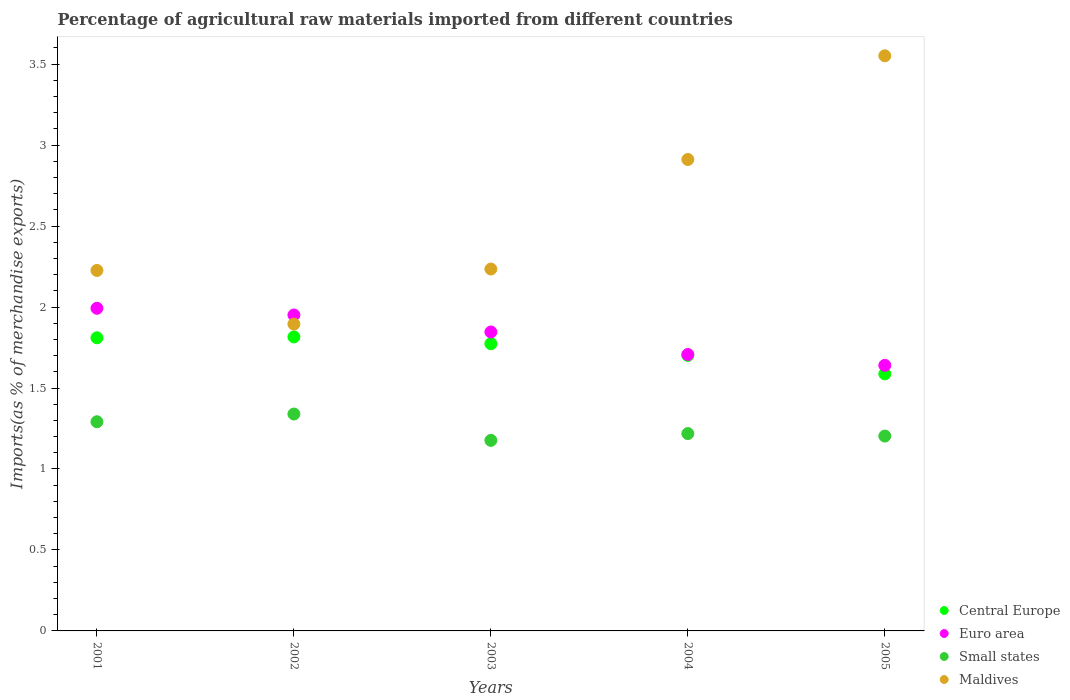How many different coloured dotlines are there?
Give a very brief answer. 4. What is the percentage of imports to different countries in Small states in 2001?
Keep it short and to the point. 1.29. Across all years, what is the maximum percentage of imports to different countries in Central Europe?
Your answer should be very brief. 1.82. Across all years, what is the minimum percentage of imports to different countries in Euro area?
Give a very brief answer. 1.64. In which year was the percentage of imports to different countries in Maldives minimum?
Give a very brief answer. 2002. What is the total percentage of imports to different countries in Maldives in the graph?
Make the answer very short. 12.82. What is the difference between the percentage of imports to different countries in Small states in 2002 and that in 2003?
Provide a short and direct response. 0.16. What is the difference between the percentage of imports to different countries in Small states in 2002 and the percentage of imports to different countries in Maldives in 2003?
Make the answer very short. -0.9. What is the average percentage of imports to different countries in Maldives per year?
Give a very brief answer. 2.56. In the year 2005, what is the difference between the percentage of imports to different countries in Central Europe and percentage of imports to different countries in Euro area?
Your response must be concise. -0.05. In how many years, is the percentage of imports to different countries in Maldives greater than 1.1 %?
Your answer should be very brief. 5. What is the ratio of the percentage of imports to different countries in Small states in 2004 to that in 2005?
Offer a terse response. 1.01. Is the percentage of imports to different countries in Euro area in 2001 less than that in 2002?
Give a very brief answer. No. What is the difference between the highest and the second highest percentage of imports to different countries in Central Europe?
Your answer should be very brief. 0.01. What is the difference between the highest and the lowest percentage of imports to different countries in Maldives?
Your response must be concise. 1.66. Is the sum of the percentage of imports to different countries in Euro area in 2001 and 2004 greater than the maximum percentage of imports to different countries in Maldives across all years?
Your answer should be compact. Yes. Is it the case that in every year, the sum of the percentage of imports to different countries in Central Europe and percentage of imports to different countries in Small states  is greater than the percentage of imports to different countries in Euro area?
Your response must be concise. Yes. Does the percentage of imports to different countries in Central Europe monotonically increase over the years?
Give a very brief answer. No. Is the percentage of imports to different countries in Central Europe strictly greater than the percentage of imports to different countries in Maldives over the years?
Keep it short and to the point. No. How many dotlines are there?
Offer a terse response. 4. What is the difference between two consecutive major ticks on the Y-axis?
Your answer should be compact. 0.5. Does the graph contain any zero values?
Keep it short and to the point. No. Does the graph contain grids?
Ensure brevity in your answer.  No. How many legend labels are there?
Provide a short and direct response. 4. What is the title of the graph?
Give a very brief answer. Percentage of agricultural raw materials imported from different countries. What is the label or title of the X-axis?
Give a very brief answer. Years. What is the label or title of the Y-axis?
Your answer should be compact. Imports(as % of merchandise exports). What is the Imports(as % of merchandise exports) in Central Europe in 2001?
Your answer should be very brief. 1.81. What is the Imports(as % of merchandise exports) in Euro area in 2001?
Ensure brevity in your answer.  1.99. What is the Imports(as % of merchandise exports) in Small states in 2001?
Make the answer very short. 1.29. What is the Imports(as % of merchandise exports) of Maldives in 2001?
Provide a short and direct response. 2.23. What is the Imports(as % of merchandise exports) in Central Europe in 2002?
Offer a terse response. 1.82. What is the Imports(as % of merchandise exports) of Euro area in 2002?
Your answer should be compact. 1.95. What is the Imports(as % of merchandise exports) in Small states in 2002?
Provide a succinct answer. 1.34. What is the Imports(as % of merchandise exports) of Maldives in 2002?
Provide a succinct answer. 1.89. What is the Imports(as % of merchandise exports) in Central Europe in 2003?
Offer a terse response. 1.77. What is the Imports(as % of merchandise exports) in Euro area in 2003?
Offer a terse response. 1.85. What is the Imports(as % of merchandise exports) of Small states in 2003?
Provide a succinct answer. 1.18. What is the Imports(as % of merchandise exports) in Maldives in 2003?
Ensure brevity in your answer.  2.23. What is the Imports(as % of merchandise exports) of Central Europe in 2004?
Your answer should be compact. 1.7. What is the Imports(as % of merchandise exports) of Euro area in 2004?
Your response must be concise. 1.71. What is the Imports(as % of merchandise exports) in Small states in 2004?
Your answer should be compact. 1.22. What is the Imports(as % of merchandise exports) of Maldives in 2004?
Give a very brief answer. 2.91. What is the Imports(as % of merchandise exports) of Central Europe in 2005?
Provide a short and direct response. 1.59. What is the Imports(as % of merchandise exports) in Euro area in 2005?
Your answer should be very brief. 1.64. What is the Imports(as % of merchandise exports) in Small states in 2005?
Make the answer very short. 1.2. What is the Imports(as % of merchandise exports) in Maldives in 2005?
Give a very brief answer. 3.55. Across all years, what is the maximum Imports(as % of merchandise exports) in Central Europe?
Give a very brief answer. 1.82. Across all years, what is the maximum Imports(as % of merchandise exports) of Euro area?
Give a very brief answer. 1.99. Across all years, what is the maximum Imports(as % of merchandise exports) of Small states?
Offer a terse response. 1.34. Across all years, what is the maximum Imports(as % of merchandise exports) of Maldives?
Offer a terse response. 3.55. Across all years, what is the minimum Imports(as % of merchandise exports) of Central Europe?
Your answer should be compact. 1.59. Across all years, what is the minimum Imports(as % of merchandise exports) in Euro area?
Make the answer very short. 1.64. Across all years, what is the minimum Imports(as % of merchandise exports) in Small states?
Your answer should be very brief. 1.18. Across all years, what is the minimum Imports(as % of merchandise exports) of Maldives?
Offer a very short reply. 1.89. What is the total Imports(as % of merchandise exports) of Central Europe in the graph?
Ensure brevity in your answer.  8.69. What is the total Imports(as % of merchandise exports) in Euro area in the graph?
Offer a very short reply. 9.14. What is the total Imports(as % of merchandise exports) in Small states in the graph?
Offer a very short reply. 6.23. What is the total Imports(as % of merchandise exports) in Maldives in the graph?
Give a very brief answer. 12.82. What is the difference between the Imports(as % of merchandise exports) of Central Europe in 2001 and that in 2002?
Offer a terse response. -0.01. What is the difference between the Imports(as % of merchandise exports) of Euro area in 2001 and that in 2002?
Offer a terse response. 0.04. What is the difference between the Imports(as % of merchandise exports) of Small states in 2001 and that in 2002?
Offer a terse response. -0.05. What is the difference between the Imports(as % of merchandise exports) in Maldives in 2001 and that in 2002?
Your response must be concise. 0.33. What is the difference between the Imports(as % of merchandise exports) of Central Europe in 2001 and that in 2003?
Your answer should be compact. 0.04. What is the difference between the Imports(as % of merchandise exports) of Euro area in 2001 and that in 2003?
Make the answer very short. 0.15. What is the difference between the Imports(as % of merchandise exports) of Small states in 2001 and that in 2003?
Your answer should be very brief. 0.12. What is the difference between the Imports(as % of merchandise exports) in Maldives in 2001 and that in 2003?
Your response must be concise. -0.01. What is the difference between the Imports(as % of merchandise exports) of Central Europe in 2001 and that in 2004?
Keep it short and to the point. 0.11. What is the difference between the Imports(as % of merchandise exports) of Euro area in 2001 and that in 2004?
Offer a terse response. 0.29. What is the difference between the Imports(as % of merchandise exports) of Small states in 2001 and that in 2004?
Make the answer very short. 0.07. What is the difference between the Imports(as % of merchandise exports) of Maldives in 2001 and that in 2004?
Offer a very short reply. -0.69. What is the difference between the Imports(as % of merchandise exports) of Central Europe in 2001 and that in 2005?
Your response must be concise. 0.22. What is the difference between the Imports(as % of merchandise exports) of Euro area in 2001 and that in 2005?
Make the answer very short. 0.35. What is the difference between the Imports(as % of merchandise exports) in Small states in 2001 and that in 2005?
Keep it short and to the point. 0.09. What is the difference between the Imports(as % of merchandise exports) in Maldives in 2001 and that in 2005?
Your response must be concise. -1.33. What is the difference between the Imports(as % of merchandise exports) of Central Europe in 2002 and that in 2003?
Give a very brief answer. 0.04. What is the difference between the Imports(as % of merchandise exports) of Euro area in 2002 and that in 2003?
Provide a succinct answer. 0.11. What is the difference between the Imports(as % of merchandise exports) in Small states in 2002 and that in 2003?
Provide a succinct answer. 0.16. What is the difference between the Imports(as % of merchandise exports) of Maldives in 2002 and that in 2003?
Your response must be concise. -0.34. What is the difference between the Imports(as % of merchandise exports) in Central Europe in 2002 and that in 2004?
Provide a succinct answer. 0.11. What is the difference between the Imports(as % of merchandise exports) in Euro area in 2002 and that in 2004?
Provide a short and direct response. 0.24. What is the difference between the Imports(as % of merchandise exports) of Small states in 2002 and that in 2004?
Your answer should be compact. 0.12. What is the difference between the Imports(as % of merchandise exports) of Maldives in 2002 and that in 2004?
Offer a terse response. -1.02. What is the difference between the Imports(as % of merchandise exports) in Central Europe in 2002 and that in 2005?
Provide a succinct answer. 0.23. What is the difference between the Imports(as % of merchandise exports) in Euro area in 2002 and that in 2005?
Make the answer very short. 0.31. What is the difference between the Imports(as % of merchandise exports) of Small states in 2002 and that in 2005?
Make the answer very short. 0.14. What is the difference between the Imports(as % of merchandise exports) of Maldives in 2002 and that in 2005?
Provide a succinct answer. -1.66. What is the difference between the Imports(as % of merchandise exports) of Central Europe in 2003 and that in 2004?
Make the answer very short. 0.07. What is the difference between the Imports(as % of merchandise exports) in Euro area in 2003 and that in 2004?
Your answer should be very brief. 0.14. What is the difference between the Imports(as % of merchandise exports) of Small states in 2003 and that in 2004?
Make the answer very short. -0.04. What is the difference between the Imports(as % of merchandise exports) of Maldives in 2003 and that in 2004?
Provide a succinct answer. -0.68. What is the difference between the Imports(as % of merchandise exports) in Central Europe in 2003 and that in 2005?
Give a very brief answer. 0.19. What is the difference between the Imports(as % of merchandise exports) in Euro area in 2003 and that in 2005?
Make the answer very short. 0.21. What is the difference between the Imports(as % of merchandise exports) of Small states in 2003 and that in 2005?
Your answer should be compact. -0.03. What is the difference between the Imports(as % of merchandise exports) in Maldives in 2003 and that in 2005?
Keep it short and to the point. -1.32. What is the difference between the Imports(as % of merchandise exports) in Central Europe in 2004 and that in 2005?
Make the answer very short. 0.11. What is the difference between the Imports(as % of merchandise exports) in Euro area in 2004 and that in 2005?
Offer a very short reply. 0.07. What is the difference between the Imports(as % of merchandise exports) of Small states in 2004 and that in 2005?
Make the answer very short. 0.02. What is the difference between the Imports(as % of merchandise exports) of Maldives in 2004 and that in 2005?
Offer a terse response. -0.64. What is the difference between the Imports(as % of merchandise exports) in Central Europe in 2001 and the Imports(as % of merchandise exports) in Euro area in 2002?
Offer a very short reply. -0.14. What is the difference between the Imports(as % of merchandise exports) in Central Europe in 2001 and the Imports(as % of merchandise exports) in Small states in 2002?
Keep it short and to the point. 0.47. What is the difference between the Imports(as % of merchandise exports) in Central Europe in 2001 and the Imports(as % of merchandise exports) in Maldives in 2002?
Keep it short and to the point. -0.08. What is the difference between the Imports(as % of merchandise exports) of Euro area in 2001 and the Imports(as % of merchandise exports) of Small states in 2002?
Provide a short and direct response. 0.65. What is the difference between the Imports(as % of merchandise exports) of Euro area in 2001 and the Imports(as % of merchandise exports) of Maldives in 2002?
Make the answer very short. 0.1. What is the difference between the Imports(as % of merchandise exports) in Small states in 2001 and the Imports(as % of merchandise exports) in Maldives in 2002?
Your answer should be very brief. -0.6. What is the difference between the Imports(as % of merchandise exports) of Central Europe in 2001 and the Imports(as % of merchandise exports) of Euro area in 2003?
Give a very brief answer. -0.04. What is the difference between the Imports(as % of merchandise exports) of Central Europe in 2001 and the Imports(as % of merchandise exports) of Small states in 2003?
Give a very brief answer. 0.63. What is the difference between the Imports(as % of merchandise exports) of Central Europe in 2001 and the Imports(as % of merchandise exports) of Maldives in 2003?
Provide a succinct answer. -0.42. What is the difference between the Imports(as % of merchandise exports) in Euro area in 2001 and the Imports(as % of merchandise exports) in Small states in 2003?
Your answer should be very brief. 0.82. What is the difference between the Imports(as % of merchandise exports) in Euro area in 2001 and the Imports(as % of merchandise exports) in Maldives in 2003?
Offer a terse response. -0.24. What is the difference between the Imports(as % of merchandise exports) in Small states in 2001 and the Imports(as % of merchandise exports) in Maldives in 2003?
Provide a short and direct response. -0.94. What is the difference between the Imports(as % of merchandise exports) of Central Europe in 2001 and the Imports(as % of merchandise exports) of Euro area in 2004?
Your answer should be compact. 0.1. What is the difference between the Imports(as % of merchandise exports) of Central Europe in 2001 and the Imports(as % of merchandise exports) of Small states in 2004?
Keep it short and to the point. 0.59. What is the difference between the Imports(as % of merchandise exports) of Central Europe in 2001 and the Imports(as % of merchandise exports) of Maldives in 2004?
Your response must be concise. -1.1. What is the difference between the Imports(as % of merchandise exports) in Euro area in 2001 and the Imports(as % of merchandise exports) in Small states in 2004?
Provide a succinct answer. 0.77. What is the difference between the Imports(as % of merchandise exports) in Euro area in 2001 and the Imports(as % of merchandise exports) in Maldives in 2004?
Keep it short and to the point. -0.92. What is the difference between the Imports(as % of merchandise exports) of Small states in 2001 and the Imports(as % of merchandise exports) of Maldives in 2004?
Give a very brief answer. -1.62. What is the difference between the Imports(as % of merchandise exports) in Central Europe in 2001 and the Imports(as % of merchandise exports) in Euro area in 2005?
Provide a succinct answer. 0.17. What is the difference between the Imports(as % of merchandise exports) in Central Europe in 2001 and the Imports(as % of merchandise exports) in Small states in 2005?
Ensure brevity in your answer.  0.61. What is the difference between the Imports(as % of merchandise exports) of Central Europe in 2001 and the Imports(as % of merchandise exports) of Maldives in 2005?
Offer a terse response. -1.74. What is the difference between the Imports(as % of merchandise exports) of Euro area in 2001 and the Imports(as % of merchandise exports) of Small states in 2005?
Your answer should be compact. 0.79. What is the difference between the Imports(as % of merchandise exports) of Euro area in 2001 and the Imports(as % of merchandise exports) of Maldives in 2005?
Your answer should be very brief. -1.56. What is the difference between the Imports(as % of merchandise exports) of Small states in 2001 and the Imports(as % of merchandise exports) of Maldives in 2005?
Offer a very short reply. -2.26. What is the difference between the Imports(as % of merchandise exports) in Central Europe in 2002 and the Imports(as % of merchandise exports) in Euro area in 2003?
Keep it short and to the point. -0.03. What is the difference between the Imports(as % of merchandise exports) of Central Europe in 2002 and the Imports(as % of merchandise exports) of Small states in 2003?
Your answer should be very brief. 0.64. What is the difference between the Imports(as % of merchandise exports) in Central Europe in 2002 and the Imports(as % of merchandise exports) in Maldives in 2003?
Offer a very short reply. -0.42. What is the difference between the Imports(as % of merchandise exports) in Euro area in 2002 and the Imports(as % of merchandise exports) in Small states in 2003?
Ensure brevity in your answer.  0.77. What is the difference between the Imports(as % of merchandise exports) of Euro area in 2002 and the Imports(as % of merchandise exports) of Maldives in 2003?
Make the answer very short. -0.28. What is the difference between the Imports(as % of merchandise exports) of Small states in 2002 and the Imports(as % of merchandise exports) of Maldives in 2003?
Provide a short and direct response. -0.9. What is the difference between the Imports(as % of merchandise exports) in Central Europe in 2002 and the Imports(as % of merchandise exports) in Euro area in 2004?
Your response must be concise. 0.11. What is the difference between the Imports(as % of merchandise exports) of Central Europe in 2002 and the Imports(as % of merchandise exports) of Small states in 2004?
Your response must be concise. 0.6. What is the difference between the Imports(as % of merchandise exports) of Central Europe in 2002 and the Imports(as % of merchandise exports) of Maldives in 2004?
Your response must be concise. -1.1. What is the difference between the Imports(as % of merchandise exports) of Euro area in 2002 and the Imports(as % of merchandise exports) of Small states in 2004?
Offer a very short reply. 0.73. What is the difference between the Imports(as % of merchandise exports) in Euro area in 2002 and the Imports(as % of merchandise exports) in Maldives in 2004?
Offer a terse response. -0.96. What is the difference between the Imports(as % of merchandise exports) of Small states in 2002 and the Imports(as % of merchandise exports) of Maldives in 2004?
Provide a succinct answer. -1.57. What is the difference between the Imports(as % of merchandise exports) in Central Europe in 2002 and the Imports(as % of merchandise exports) in Euro area in 2005?
Make the answer very short. 0.18. What is the difference between the Imports(as % of merchandise exports) of Central Europe in 2002 and the Imports(as % of merchandise exports) of Small states in 2005?
Give a very brief answer. 0.61. What is the difference between the Imports(as % of merchandise exports) in Central Europe in 2002 and the Imports(as % of merchandise exports) in Maldives in 2005?
Ensure brevity in your answer.  -1.74. What is the difference between the Imports(as % of merchandise exports) in Euro area in 2002 and the Imports(as % of merchandise exports) in Small states in 2005?
Your answer should be very brief. 0.75. What is the difference between the Imports(as % of merchandise exports) of Euro area in 2002 and the Imports(as % of merchandise exports) of Maldives in 2005?
Keep it short and to the point. -1.6. What is the difference between the Imports(as % of merchandise exports) of Small states in 2002 and the Imports(as % of merchandise exports) of Maldives in 2005?
Offer a very short reply. -2.21. What is the difference between the Imports(as % of merchandise exports) of Central Europe in 2003 and the Imports(as % of merchandise exports) of Euro area in 2004?
Provide a succinct answer. 0.07. What is the difference between the Imports(as % of merchandise exports) in Central Europe in 2003 and the Imports(as % of merchandise exports) in Small states in 2004?
Ensure brevity in your answer.  0.56. What is the difference between the Imports(as % of merchandise exports) in Central Europe in 2003 and the Imports(as % of merchandise exports) in Maldives in 2004?
Ensure brevity in your answer.  -1.14. What is the difference between the Imports(as % of merchandise exports) in Euro area in 2003 and the Imports(as % of merchandise exports) in Small states in 2004?
Make the answer very short. 0.63. What is the difference between the Imports(as % of merchandise exports) in Euro area in 2003 and the Imports(as % of merchandise exports) in Maldives in 2004?
Provide a succinct answer. -1.07. What is the difference between the Imports(as % of merchandise exports) of Small states in 2003 and the Imports(as % of merchandise exports) of Maldives in 2004?
Ensure brevity in your answer.  -1.73. What is the difference between the Imports(as % of merchandise exports) in Central Europe in 2003 and the Imports(as % of merchandise exports) in Euro area in 2005?
Provide a succinct answer. 0.13. What is the difference between the Imports(as % of merchandise exports) of Central Europe in 2003 and the Imports(as % of merchandise exports) of Small states in 2005?
Your response must be concise. 0.57. What is the difference between the Imports(as % of merchandise exports) in Central Europe in 2003 and the Imports(as % of merchandise exports) in Maldives in 2005?
Your answer should be compact. -1.78. What is the difference between the Imports(as % of merchandise exports) of Euro area in 2003 and the Imports(as % of merchandise exports) of Small states in 2005?
Make the answer very short. 0.64. What is the difference between the Imports(as % of merchandise exports) of Euro area in 2003 and the Imports(as % of merchandise exports) of Maldives in 2005?
Provide a short and direct response. -1.71. What is the difference between the Imports(as % of merchandise exports) of Small states in 2003 and the Imports(as % of merchandise exports) of Maldives in 2005?
Offer a very short reply. -2.37. What is the difference between the Imports(as % of merchandise exports) in Central Europe in 2004 and the Imports(as % of merchandise exports) in Euro area in 2005?
Make the answer very short. 0.06. What is the difference between the Imports(as % of merchandise exports) of Central Europe in 2004 and the Imports(as % of merchandise exports) of Small states in 2005?
Your answer should be compact. 0.5. What is the difference between the Imports(as % of merchandise exports) in Central Europe in 2004 and the Imports(as % of merchandise exports) in Maldives in 2005?
Give a very brief answer. -1.85. What is the difference between the Imports(as % of merchandise exports) of Euro area in 2004 and the Imports(as % of merchandise exports) of Small states in 2005?
Provide a short and direct response. 0.5. What is the difference between the Imports(as % of merchandise exports) in Euro area in 2004 and the Imports(as % of merchandise exports) in Maldives in 2005?
Offer a very short reply. -1.84. What is the difference between the Imports(as % of merchandise exports) of Small states in 2004 and the Imports(as % of merchandise exports) of Maldives in 2005?
Offer a very short reply. -2.33. What is the average Imports(as % of merchandise exports) of Central Europe per year?
Provide a short and direct response. 1.74. What is the average Imports(as % of merchandise exports) in Euro area per year?
Provide a short and direct response. 1.83. What is the average Imports(as % of merchandise exports) of Small states per year?
Your answer should be compact. 1.25. What is the average Imports(as % of merchandise exports) of Maldives per year?
Offer a very short reply. 2.56. In the year 2001, what is the difference between the Imports(as % of merchandise exports) in Central Europe and Imports(as % of merchandise exports) in Euro area?
Your answer should be compact. -0.18. In the year 2001, what is the difference between the Imports(as % of merchandise exports) of Central Europe and Imports(as % of merchandise exports) of Small states?
Provide a succinct answer. 0.52. In the year 2001, what is the difference between the Imports(as % of merchandise exports) in Central Europe and Imports(as % of merchandise exports) in Maldives?
Offer a very short reply. -0.42. In the year 2001, what is the difference between the Imports(as % of merchandise exports) in Euro area and Imports(as % of merchandise exports) in Small states?
Offer a very short reply. 0.7. In the year 2001, what is the difference between the Imports(as % of merchandise exports) in Euro area and Imports(as % of merchandise exports) in Maldives?
Provide a succinct answer. -0.23. In the year 2001, what is the difference between the Imports(as % of merchandise exports) in Small states and Imports(as % of merchandise exports) in Maldives?
Ensure brevity in your answer.  -0.93. In the year 2002, what is the difference between the Imports(as % of merchandise exports) of Central Europe and Imports(as % of merchandise exports) of Euro area?
Your answer should be very brief. -0.14. In the year 2002, what is the difference between the Imports(as % of merchandise exports) of Central Europe and Imports(as % of merchandise exports) of Small states?
Keep it short and to the point. 0.48. In the year 2002, what is the difference between the Imports(as % of merchandise exports) in Central Europe and Imports(as % of merchandise exports) in Maldives?
Provide a short and direct response. -0.08. In the year 2002, what is the difference between the Imports(as % of merchandise exports) in Euro area and Imports(as % of merchandise exports) in Small states?
Ensure brevity in your answer.  0.61. In the year 2002, what is the difference between the Imports(as % of merchandise exports) in Euro area and Imports(as % of merchandise exports) in Maldives?
Offer a terse response. 0.06. In the year 2002, what is the difference between the Imports(as % of merchandise exports) of Small states and Imports(as % of merchandise exports) of Maldives?
Offer a very short reply. -0.56. In the year 2003, what is the difference between the Imports(as % of merchandise exports) in Central Europe and Imports(as % of merchandise exports) in Euro area?
Provide a succinct answer. -0.07. In the year 2003, what is the difference between the Imports(as % of merchandise exports) in Central Europe and Imports(as % of merchandise exports) in Small states?
Give a very brief answer. 0.6. In the year 2003, what is the difference between the Imports(as % of merchandise exports) of Central Europe and Imports(as % of merchandise exports) of Maldives?
Provide a succinct answer. -0.46. In the year 2003, what is the difference between the Imports(as % of merchandise exports) in Euro area and Imports(as % of merchandise exports) in Small states?
Provide a succinct answer. 0.67. In the year 2003, what is the difference between the Imports(as % of merchandise exports) of Euro area and Imports(as % of merchandise exports) of Maldives?
Provide a succinct answer. -0.39. In the year 2003, what is the difference between the Imports(as % of merchandise exports) in Small states and Imports(as % of merchandise exports) in Maldives?
Your response must be concise. -1.06. In the year 2004, what is the difference between the Imports(as % of merchandise exports) of Central Europe and Imports(as % of merchandise exports) of Euro area?
Make the answer very short. -0.01. In the year 2004, what is the difference between the Imports(as % of merchandise exports) of Central Europe and Imports(as % of merchandise exports) of Small states?
Your answer should be very brief. 0.48. In the year 2004, what is the difference between the Imports(as % of merchandise exports) in Central Europe and Imports(as % of merchandise exports) in Maldives?
Give a very brief answer. -1.21. In the year 2004, what is the difference between the Imports(as % of merchandise exports) in Euro area and Imports(as % of merchandise exports) in Small states?
Provide a short and direct response. 0.49. In the year 2004, what is the difference between the Imports(as % of merchandise exports) of Euro area and Imports(as % of merchandise exports) of Maldives?
Keep it short and to the point. -1.2. In the year 2004, what is the difference between the Imports(as % of merchandise exports) of Small states and Imports(as % of merchandise exports) of Maldives?
Make the answer very short. -1.69. In the year 2005, what is the difference between the Imports(as % of merchandise exports) of Central Europe and Imports(as % of merchandise exports) of Euro area?
Provide a short and direct response. -0.05. In the year 2005, what is the difference between the Imports(as % of merchandise exports) of Central Europe and Imports(as % of merchandise exports) of Small states?
Your response must be concise. 0.38. In the year 2005, what is the difference between the Imports(as % of merchandise exports) of Central Europe and Imports(as % of merchandise exports) of Maldives?
Keep it short and to the point. -1.96. In the year 2005, what is the difference between the Imports(as % of merchandise exports) of Euro area and Imports(as % of merchandise exports) of Small states?
Your response must be concise. 0.44. In the year 2005, what is the difference between the Imports(as % of merchandise exports) in Euro area and Imports(as % of merchandise exports) in Maldives?
Ensure brevity in your answer.  -1.91. In the year 2005, what is the difference between the Imports(as % of merchandise exports) of Small states and Imports(as % of merchandise exports) of Maldives?
Offer a terse response. -2.35. What is the ratio of the Imports(as % of merchandise exports) of Central Europe in 2001 to that in 2002?
Provide a succinct answer. 1. What is the ratio of the Imports(as % of merchandise exports) of Euro area in 2001 to that in 2002?
Give a very brief answer. 1.02. What is the ratio of the Imports(as % of merchandise exports) in Small states in 2001 to that in 2002?
Give a very brief answer. 0.96. What is the ratio of the Imports(as % of merchandise exports) of Maldives in 2001 to that in 2002?
Your answer should be compact. 1.17. What is the ratio of the Imports(as % of merchandise exports) in Central Europe in 2001 to that in 2003?
Give a very brief answer. 1.02. What is the ratio of the Imports(as % of merchandise exports) of Euro area in 2001 to that in 2003?
Provide a succinct answer. 1.08. What is the ratio of the Imports(as % of merchandise exports) of Small states in 2001 to that in 2003?
Offer a terse response. 1.1. What is the ratio of the Imports(as % of merchandise exports) of Maldives in 2001 to that in 2003?
Your answer should be very brief. 1. What is the ratio of the Imports(as % of merchandise exports) in Central Europe in 2001 to that in 2004?
Provide a short and direct response. 1.06. What is the ratio of the Imports(as % of merchandise exports) in Euro area in 2001 to that in 2004?
Your answer should be compact. 1.17. What is the ratio of the Imports(as % of merchandise exports) in Small states in 2001 to that in 2004?
Give a very brief answer. 1.06. What is the ratio of the Imports(as % of merchandise exports) of Maldives in 2001 to that in 2004?
Ensure brevity in your answer.  0.76. What is the ratio of the Imports(as % of merchandise exports) of Central Europe in 2001 to that in 2005?
Your answer should be compact. 1.14. What is the ratio of the Imports(as % of merchandise exports) of Euro area in 2001 to that in 2005?
Your response must be concise. 1.21. What is the ratio of the Imports(as % of merchandise exports) of Small states in 2001 to that in 2005?
Make the answer very short. 1.07. What is the ratio of the Imports(as % of merchandise exports) of Maldives in 2001 to that in 2005?
Offer a very short reply. 0.63. What is the ratio of the Imports(as % of merchandise exports) of Central Europe in 2002 to that in 2003?
Keep it short and to the point. 1.02. What is the ratio of the Imports(as % of merchandise exports) in Euro area in 2002 to that in 2003?
Offer a very short reply. 1.06. What is the ratio of the Imports(as % of merchandise exports) of Small states in 2002 to that in 2003?
Your response must be concise. 1.14. What is the ratio of the Imports(as % of merchandise exports) in Maldives in 2002 to that in 2003?
Offer a very short reply. 0.85. What is the ratio of the Imports(as % of merchandise exports) of Central Europe in 2002 to that in 2004?
Provide a short and direct response. 1.07. What is the ratio of the Imports(as % of merchandise exports) of Euro area in 2002 to that in 2004?
Keep it short and to the point. 1.14. What is the ratio of the Imports(as % of merchandise exports) of Small states in 2002 to that in 2004?
Ensure brevity in your answer.  1.1. What is the ratio of the Imports(as % of merchandise exports) of Maldives in 2002 to that in 2004?
Give a very brief answer. 0.65. What is the ratio of the Imports(as % of merchandise exports) of Central Europe in 2002 to that in 2005?
Offer a very short reply. 1.14. What is the ratio of the Imports(as % of merchandise exports) in Euro area in 2002 to that in 2005?
Offer a terse response. 1.19. What is the ratio of the Imports(as % of merchandise exports) in Small states in 2002 to that in 2005?
Ensure brevity in your answer.  1.11. What is the ratio of the Imports(as % of merchandise exports) in Maldives in 2002 to that in 2005?
Ensure brevity in your answer.  0.53. What is the ratio of the Imports(as % of merchandise exports) of Central Europe in 2003 to that in 2004?
Your answer should be compact. 1.04. What is the ratio of the Imports(as % of merchandise exports) of Euro area in 2003 to that in 2004?
Your answer should be compact. 1.08. What is the ratio of the Imports(as % of merchandise exports) in Small states in 2003 to that in 2004?
Ensure brevity in your answer.  0.97. What is the ratio of the Imports(as % of merchandise exports) of Maldives in 2003 to that in 2004?
Make the answer very short. 0.77. What is the ratio of the Imports(as % of merchandise exports) in Central Europe in 2003 to that in 2005?
Your response must be concise. 1.12. What is the ratio of the Imports(as % of merchandise exports) of Euro area in 2003 to that in 2005?
Give a very brief answer. 1.13. What is the ratio of the Imports(as % of merchandise exports) in Small states in 2003 to that in 2005?
Make the answer very short. 0.98. What is the ratio of the Imports(as % of merchandise exports) in Maldives in 2003 to that in 2005?
Make the answer very short. 0.63. What is the ratio of the Imports(as % of merchandise exports) of Central Europe in 2004 to that in 2005?
Make the answer very short. 1.07. What is the ratio of the Imports(as % of merchandise exports) in Euro area in 2004 to that in 2005?
Give a very brief answer. 1.04. What is the ratio of the Imports(as % of merchandise exports) in Small states in 2004 to that in 2005?
Offer a very short reply. 1.01. What is the ratio of the Imports(as % of merchandise exports) of Maldives in 2004 to that in 2005?
Ensure brevity in your answer.  0.82. What is the difference between the highest and the second highest Imports(as % of merchandise exports) of Central Europe?
Provide a short and direct response. 0.01. What is the difference between the highest and the second highest Imports(as % of merchandise exports) of Euro area?
Provide a succinct answer. 0.04. What is the difference between the highest and the second highest Imports(as % of merchandise exports) in Small states?
Provide a succinct answer. 0.05. What is the difference between the highest and the second highest Imports(as % of merchandise exports) in Maldives?
Keep it short and to the point. 0.64. What is the difference between the highest and the lowest Imports(as % of merchandise exports) of Central Europe?
Ensure brevity in your answer.  0.23. What is the difference between the highest and the lowest Imports(as % of merchandise exports) in Euro area?
Your answer should be very brief. 0.35. What is the difference between the highest and the lowest Imports(as % of merchandise exports) of Small states?
Your answer should be compact. 0.16. What is the difference between the highest and the lowest Imports(as % of merchandise exports) of Maldives?
Give a very brief answer. 1.66. 